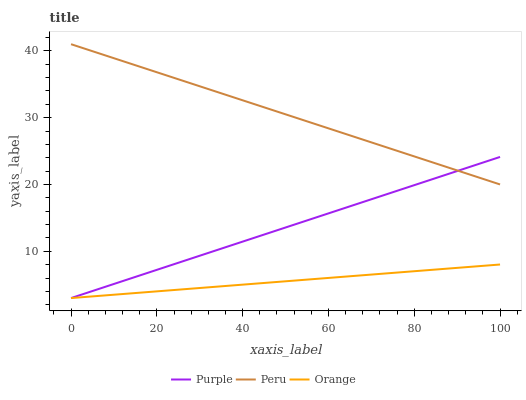Does Orange have the minimum area under the curve?
Answer yes or no. Yes. Does Peru have the maximum area under the curve?
Answer yes or no. Yes. Does Peru have the minimum area under the curve?
Answer yes or no. No. Does Orange have the maximum area under the curve?
Answer yes or no. No. Is Orange the smoothest?
Answer yes or no. Yes. Is Peru the roughest?
Answer yes or no. Yes. Is Peru the smoothest?
Answer yes or no. No. Is Orange the roughest?
Answer yes or no. No. Does Purple have the lowest value?
Answer yes or no. Yes. Does Peru have the lowest value?
Answer yes or no. No. Does Peru have the highest value?
Answer yes or no. Yes. Does Orange have the highest value?
Answer yes or no. No. Is Orange less than Peru?
Answer yes or no. Yes. Is Peru greater than Orange?
Answer yes or no. Yes. Does Purple intersect Orange?
Answer yes or no. Yes. Is Purple less than Orange?
Answer yes or no. No. Is Purple greater than Orange?
Answer yes or no. No. Does Orange intersect Peru?
Answer yes or no. No. 